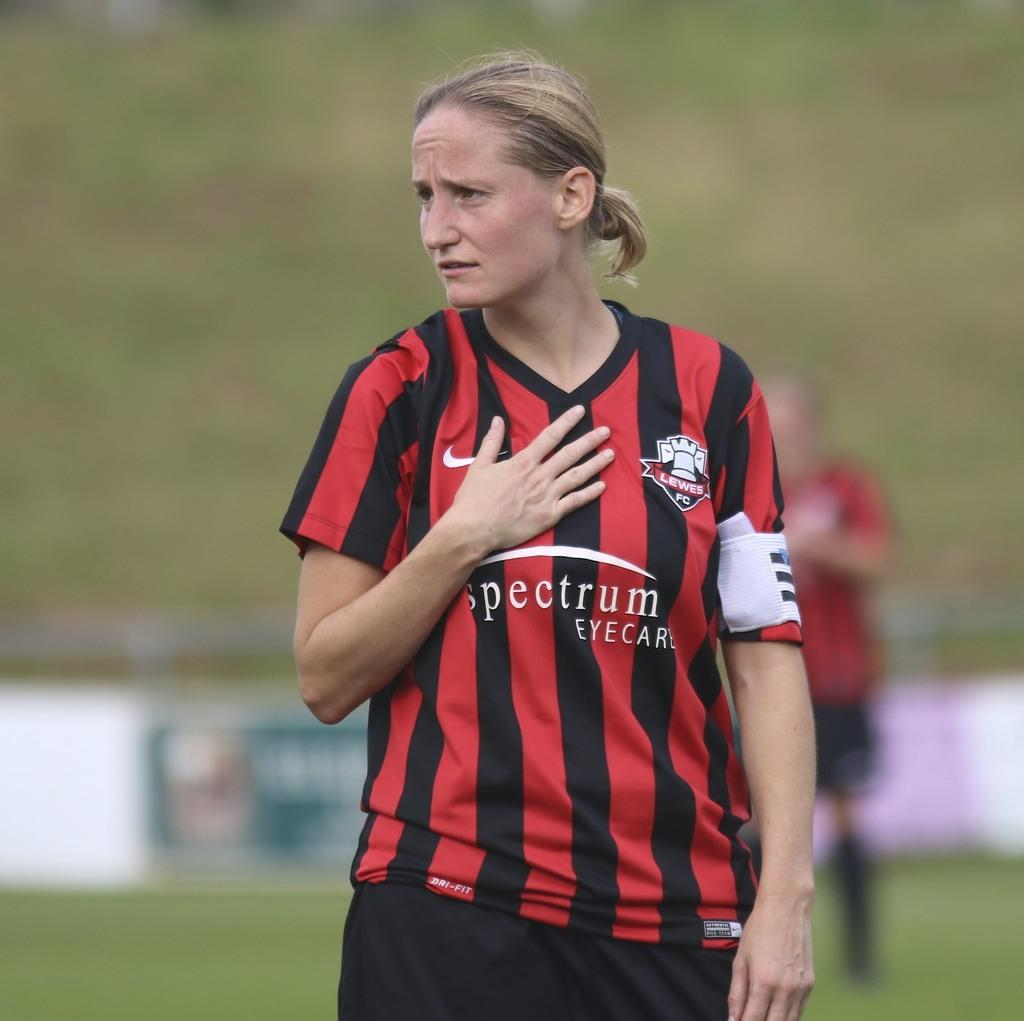<image>
Summarize the visual content of the image. A woman in a Spectrum Eye Care shirt wears a stricken expression on her face. 